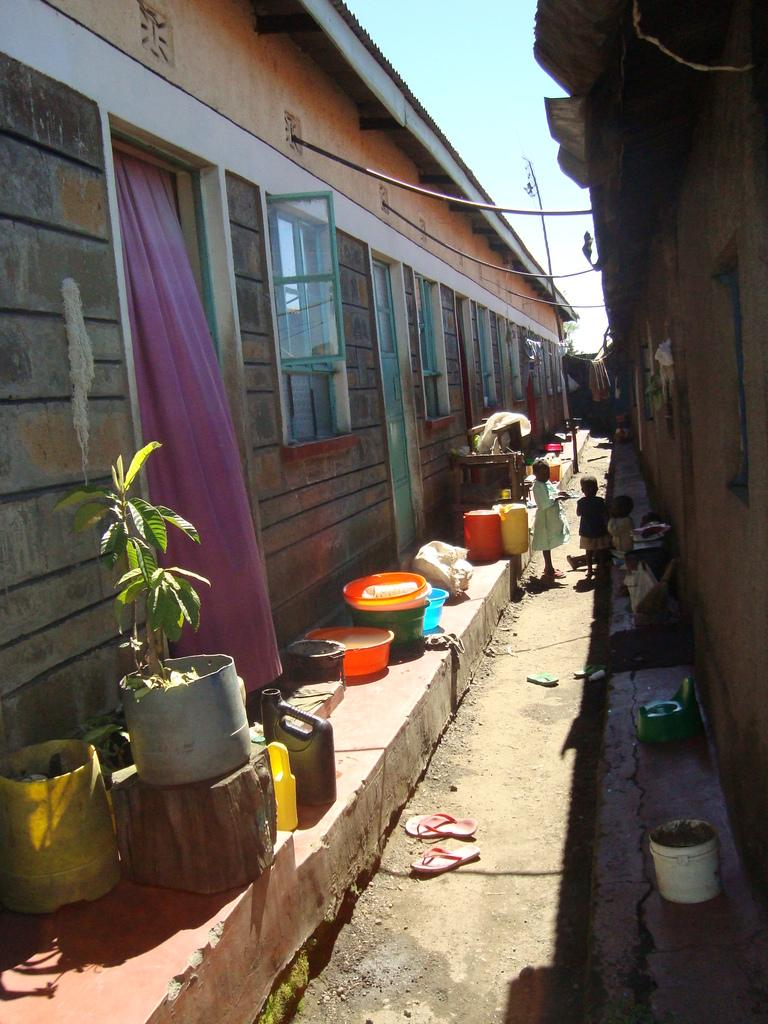What structure is present in the image? There is a building in the image. Where are the children located in relation to the building? There are two children between the buildings in the image. What objects can be seen near the children? Buckets are visible in the image. What type of container is present in the image? There is a flower pot in the image. What items are related to horses in the image? There are saddles in the image. What is visible in the background of the image? The sky is visible in the image. What color is the crayon being used by the children in the image? There is no crayon present in the image. How low are the buildings in the image? The height of the buildings cannot be determined from the image alone. What type of bottle can be seen in the image? There is no bottle present in the image. 